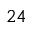<formula> <loc_0><loc_0><loc_500><loc_500>^ { 2 4 }</formula> 